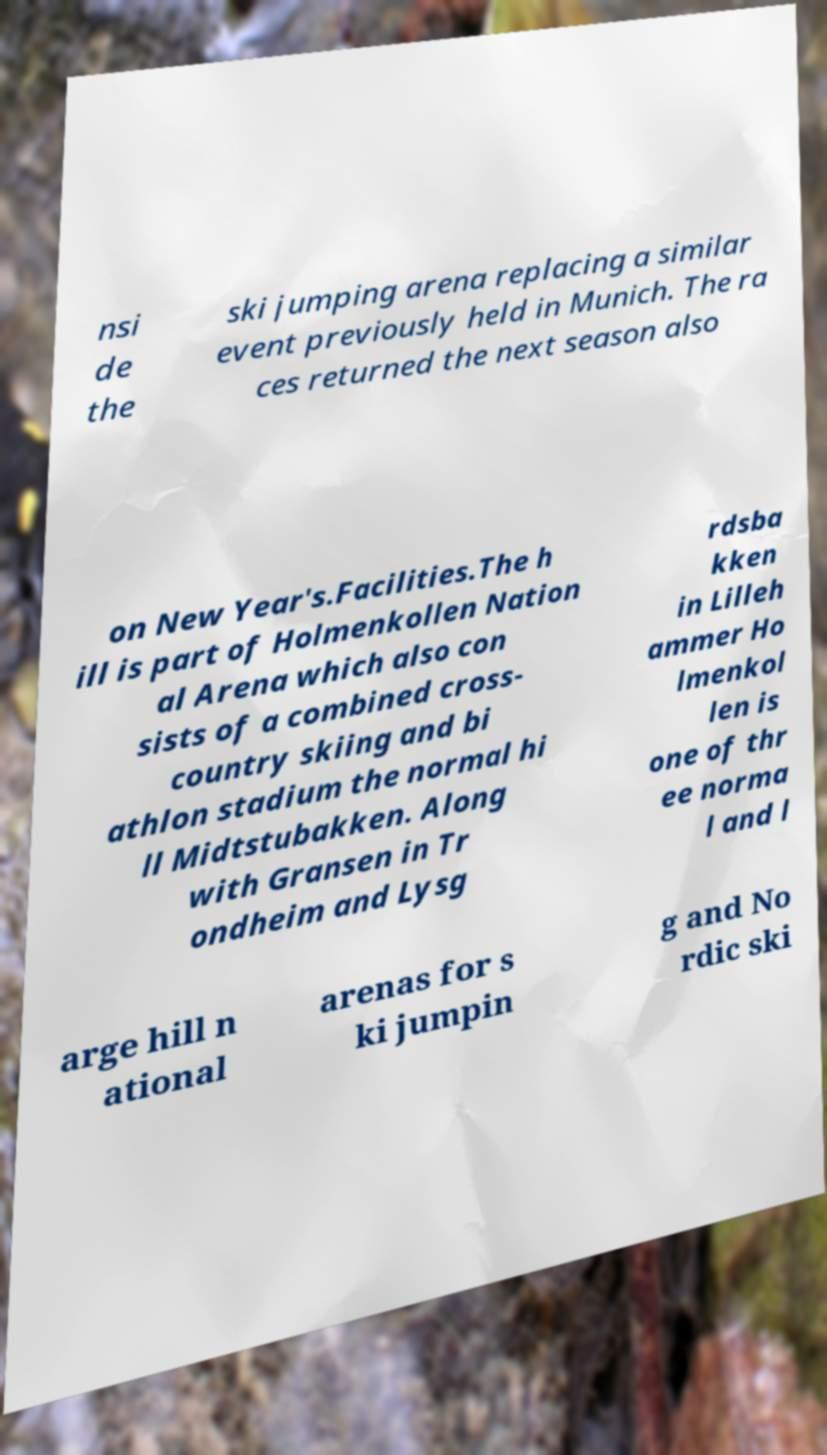Please identify and transcribe the text found in this image. nsi de the ski jumping arena replacing a similar event previously held in Munich. The ra ces returned the next season also on New Year's.Facilities.The h ill is part of Holmenkollen Nation al Arena which also con sists of a combined cross- country skiing and bi athlon stadium the normal hi ll Midtstubakken. Along with Gransen in Tr ondheim and Lysg rdsba kken in Lilleh ammer Ho lmenkol len is one of thr ee norma l and l arge hill n ational arenas for s ki jumpin g and No rdic ski 